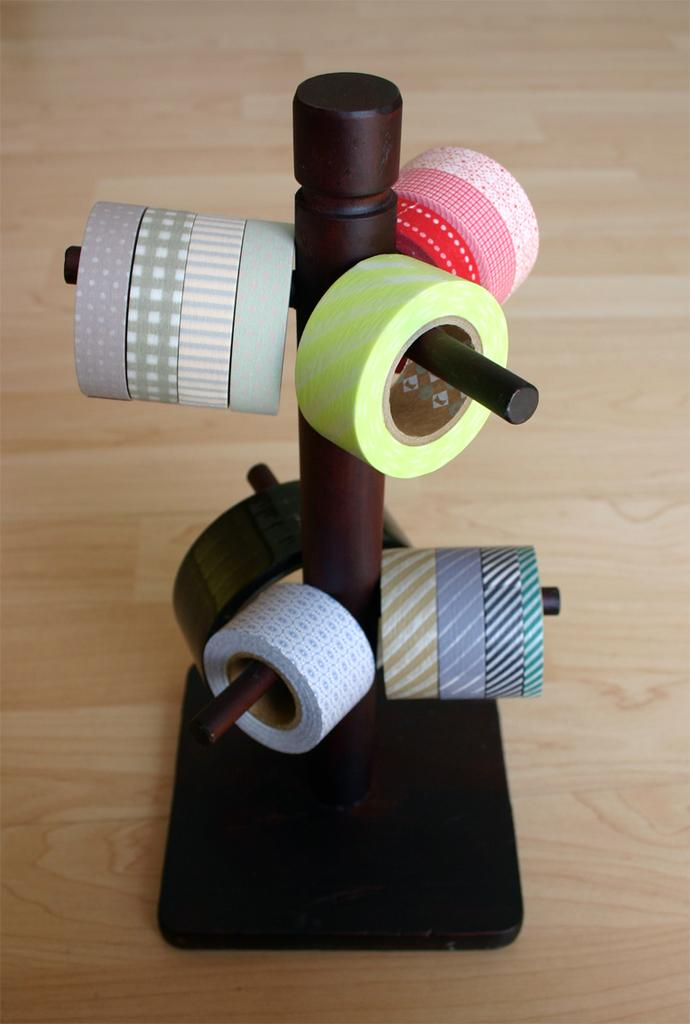What is the main object in the image? There is a wooden stand in the image. What is the wooden stand holding? The wooden stand is holding some colorful tapes. What type of ticket is being offered on the wooden stand? There is no ticket present on the wooden stand in the image. 